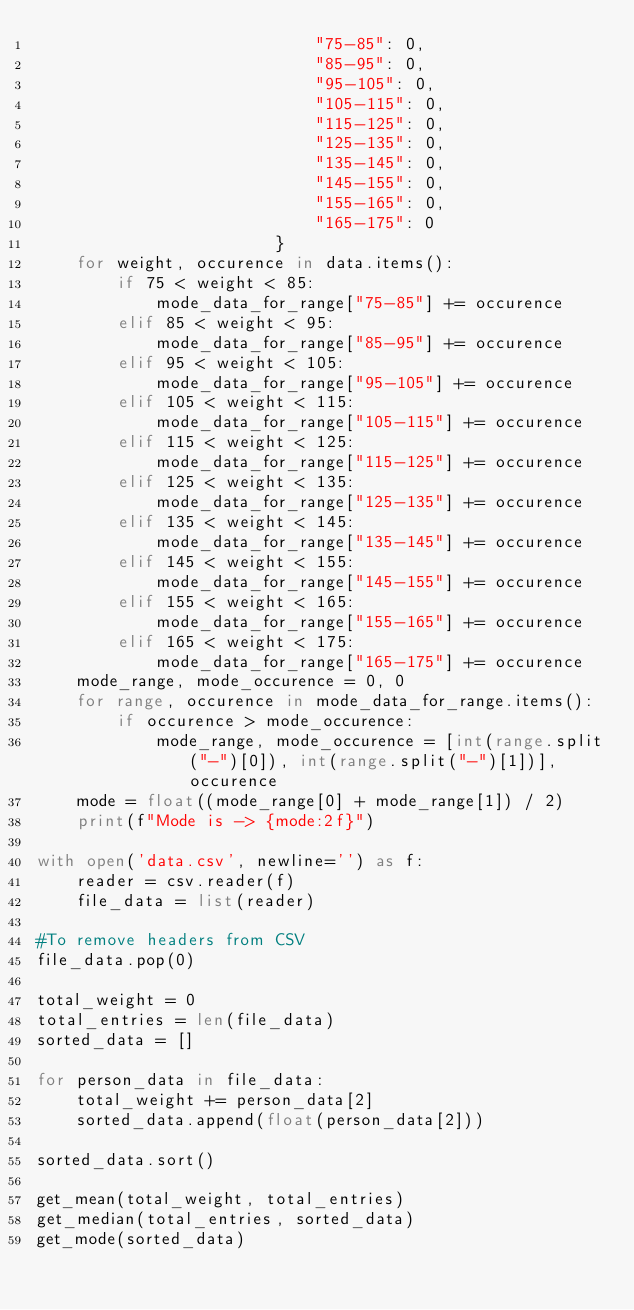<code> <loc_0><loc_0><loc_500><loc_500><_Python_>                            "75-85": 0,
                            "85-95": 0,
                            "95-105": 0,
                            "105-115": 0,
                            "115-125": 0,
                            "125-135": 0,
                            "135-145": 0,
                            "145-155": 0,
                            "155-165": 0,
                            "165-175": 0
                        }
    for weight, occurence in data.items():
        if 75 < weight < 85:
            mode_data_for_range["75-85"] += occurence
        elif 85 < weight < 95:
            mode_data_for_range["85-95"] += occurence
        elif 95 < weight < 105:
            mode_data_for_range["95-105"] += occurence
        elif 105 < weight < 115:
            mode_data_for_range["105-115"] += occurence
        elif 115 < weight < 125:
            mode_data_for_range["115-125"] += occurence
        elif 125 < weight < 135:
            mode_data_for_range["125-135"] += occurence
        elif 135 < weight < 145:
            mode_data_for_range["135-145"] += occurence
        elif 145 < weight < 155:
            mode_data_for_range["145-155"] += occurence
        elif 155 < weight < 165:
            mode_data_for_range["155-165"] += occurence
        elif 165 < weight < 175:
            mode_data_for_range["165-175"] += occurence
    mode_range, mode_occurence = 0, 0
    for range, occurence in mode_data_for_range.items():
        if occurence > mode_occurence:
            mode_range, mode_occurence = [int(range.split("-")[0]), int(range.split("-")[1])], occurence
    mode = float((mode_range[0] + mode_range[1]) / 2)
    print(f"Mode is -> {mode:2f}")

with open('data.csv', newline='') as f:
    reader = csv.reader(f)
    file_data = list(reader)

#To remove headers from CSV
file_data.pop(0)

total_weight = 0
total_entries = len(file_data)
sorted_data = []

for person_data in file_data:
    total_weight += person_data[2]
    sorted_data.append(float(person_data[2]))

sorted_data.sort()

get_mean(total_weight, total_entries)
get_median(total_entries, sorted_data)
get_mode(sorted_data)
</code> 